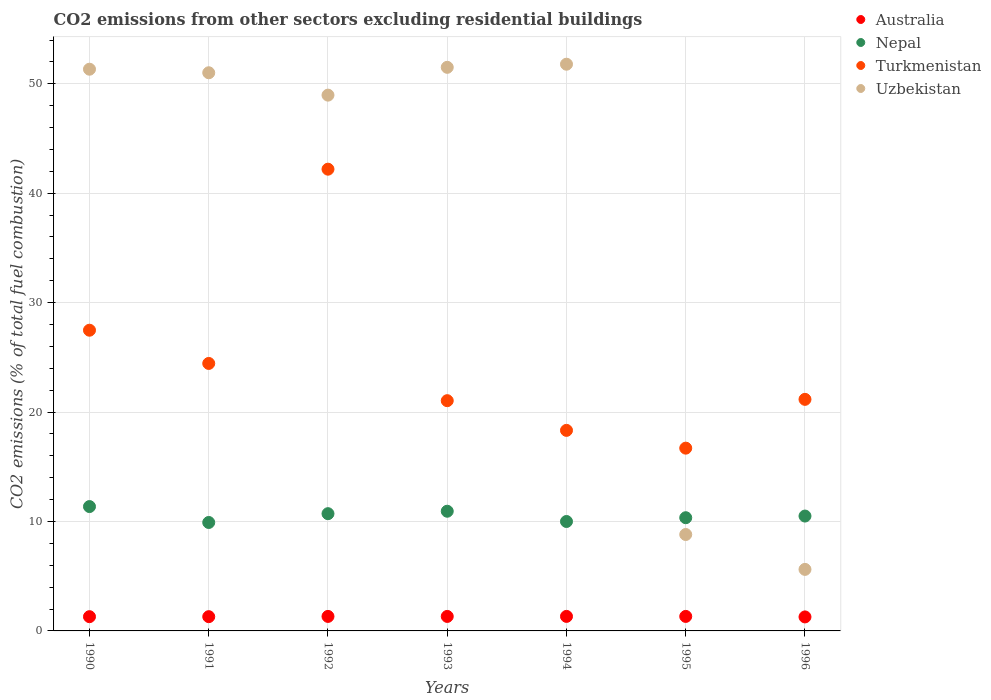What is the total CO2 emitted in Uzbekistan in 1991?
Offer a very short reply. 51.01. Across all years, what is the maximum total CO2 emitted in Turkmenistan?
Offer a terse response. 42.19. Across all years, what is the minimum total CO2 emitted in Australia?
Make the answer very short. 1.28. In which year was the total CO2 emitted in Turkmenistan maximum?
Your answer should be compact. 1992. What is the total total CO2 emitted in Uzbekistan in the graph?
Offer a terse response. 269.02. What is the difference between the total CO2 emitted in Uzbekistan in 1990 and that in 1995?
Give a very brief answer. 42.52. What is the difference between the total CO2 emitted in Uzbekistan in 1993 and the total CO2 emitted in Australia in 1996?
Ensure brevity in your answer.  50.22. What is the average total CO2 emitted in Uzbekistan per year?
Provide a short and direct response. 38.43. In the year 1996, what is the difference between the total CO2 emitted in Nepal and total CO2 emitted in Turkmenistan?
Provide a succinct answer. -10.66. In how many years, is the total CO2 emitted in Turkmenistan greater than 32?
Provide a short and direct response. 1. What is the ratio of the total CO2 emitted in Turkmenistan in 1991 to that in 1992?
Make the answer very short. 0.58. Is the total CO2 emitted in Turkmenistan in 1990 less than that in 1996?
Ensure brevity in your answer.  No. Is the difference between the total CO2 emitted in Nepal in 1990 and 1991 greater than the difference between the total CO2 emitted in Turkmenistan in 1990 and 1991?
Your response must be concise. No. What is the difference between the highest and the second highest total CO2 emitted in Nepal?
Keep it short and to the point. 0.43. What is the difference between the highest and the lowest total CO2 emitted in Uzbekistan?
Your response must be concise. 46.16. In how many years, is the total CO2 emitted in Turkmenistan greater than the average total CO2 emitted in Turkmenistan taken over all years?
Your response must be concise. 2. Is it the case that in every year, the sum of the total CO2 emitted in Turkmenistan and total CO2 emitted in Uzbekistan  is greater than the total CO2 emitted in Australia?
Provide a succinct answer. Yes. Is the total CO2 emitted in Nepal strictly greater than the total CO2 emitted in Turkmenistan over the years?
Provide a succinct answer. No. Is the total CO2 emitted in Australia strictly less than the total CO2 emitted in Turkmenistan over the years?
Your answer should be very brief. Yes. How many dotlines are there?
Offer a very short reply. 4. What is the difference between two consecutive major ticks on the Y-axis?
Provide a succinct answer. 10. Are the values on the major ticks of Y-axis written in scientific E-notation?
Ensure brevity in your answer.  No. Does the graph contain any zero values?
Keep it short and to the point. No. Does the graph contain grids?
Provide a short and direct response. Yes. How many legend labels are there?
Your response must be concise. 4. How are the legend labels stacked?
Your answer should be compact. Vertical. What is the title of the graph?
Provide a succinct answer. CO2 emissions from other sectors excluding residential buildings. Does "Antigua and Barbuda" appear as one of the legend labels in the graph?
Provide a succinct answer. No. What is the label or title of the Y-axis?
Your response must be concise. CO2 emissions (% of total fuel combustion). What is the CO2 emissions (% of total fuel combustion) of Australia in 1990?
Keep it short and to the point. 1.3. What is the CO2 emissions (% of total fuel combustion) of Nepal in 1990?
Provide a short and direct response. 11.36. What is the CO2 emissions (% of total fuel combustion) of Turkmenistan in 1990?
Your answer should be very brief. 27.48. What is the CO2 emissions (% of total fuel combustion) of Uzbekistan in 1990?
Give a very brief answer. 51.33. What is the CO2 emissions (% of total fuel combustion) in Australia in 1991?
Give a very brief answer. 1.3. What is the CO2 emissions (% of total fuel combustion) in Nepal in 1991?
Make the answer very short. 9.91. What is the CO2 emissions (% of total fuel combustion) in Turkmenistan in 1991?
Your response must be concise. 24.44. What is the CO2 emissions (% of total fuel combustion) in Uzbekistan in 1991?
Your response must be concise. 51.01. What is the CO2 emissions (% of total fuel combustion) of Australia in 1992?
Give a very brief answer. 1.33. What is the CO2 emissions (% of total fuel combustion) in Nepal in 1992?
Provide a short and direct response. 10.71. What is the CO2 emissions (% of total fuel combustion) of Turkmenistan in 1992?
Make the answer very short. 42.19. What is the CO2 emissions (% of total fuel combustion) of Uzbekistan in 1992?
Ensure brevity in your answer.  48.96. What is the CO2 emissions (% of total fuel combustion) of Australia in 1993?
Keep it short and to the point. 1.32. What is the CO2 emissions (% of total fuel combustion) of Nepal in 1993?
Provide a succinct answer. 10.94. What is the CO2 emissions (% of total fuel combustion) of Turkmenistan in 1993?
Your answer should be compact. 21.04. What is the CO2 emissions (% of total fuel combustion) in Uzbekistan in 1993?
Your answer should be very brief. 51.5. What is the CO2 emissions (% of total fuel combustion) of Australia in 1994?
Your answer should be compact. 1.33. What is the CO2 emissions (% of total fuel combustion) of Nepal in 1994?
Provide a succinct answer. 10. What is the CO2 emissions (% of total fuel combustion) in Turkmenistan in 1994?
Provide a short and direct response. 18.33. What is the CO2 emissions (% of total fuel combustion) in Uzbekistan in 1994?
Your answer should be very brief. 51.79. What is the CO2 emissions (% of total fuel combustion) of Australia in 1995?
Keep it short and to the point. 1.33. What is the CO2 emissions (% of total fuel combustion) in Nepal in 1995?
Your response must be concise. 10.34. What is the CO2 emissions (% of total fuel combustion) of Turkmenistan in 1995?
Your answer should be very brief. 16.7. What is the CO2 emissions (% of total fuel combustion) in Uzbekistan in 1995?
Offer a very short reply. 8.81. What is the CO2 emissions (% of total fuel combustion) of Australia in 1996?
Your answer should be very brief. 1.28. What is the CO2 emissions (% of total fuel combustion) in Nepal in 1996?
Make the answer very short. 10.5. What is the CO2 emissions (% of total fuel combustion) of Turkmenistan in 1996?
Offer a terse response. 21.16. What is the CO2 emissions (% of total fuel combustion) in Uzbekistan in 1996?
Your answer should be compact. 5.62. Across all years, what is the maximum CO2 emissions (% of total fuel combustion) in Australia?
Ensure brevity in your answer.  1.33. Across all years, what is the maximum CO2 emissions (% of total fuel combustion) of Nepal?
Ensure brevity in your answer.  11.36. Across all years, what is the maximum CO2 emissions (% of total fuel combustion) of Turkmenistan?
Keep it short and to the point. 42.19. Across all years, what is the maximum CO2 emissions (% of total fuel combustion) of Uzbekistan?
Make the answer very short. 51.79. Across all years, what is the minimum CO2 emissions (% of total fuel combustion) in Australia?
Give a very brief answer. 1.28. Across all years, what is the minimum CO2 emissions (% of total fuel combustion) in Nepal?
Provide a succinct answer. 9.91. Across all years, what is the minimum CO2 emissions (% of total fuel combustion) in Turkmenistan?
Keep it short and to the point. 16.7. Across all years, what is the minimum CO2 emissions (% of total fuel combustion) of Uzbekistan?
Offer a very short reply. 5.62. What is the total CO2 emissions (% of total fuel combustion) in Australia in the graph?
Provide a short and direct response. 9.19. What is the total CO2 emissions (% of total fuel combustion) in Nepal in the graph?
Ensure brevity in your answer.  73.77. What is the total CO2 emissions (% of total fuel combustion) in Turkmenistan in the graph?
Keep it short and to the point. 171.35. What is the total CO2 emissions (% of total fuel combustion) of Uzbekistan in the graph?
Ensure brevity in your answer.  269.02. What is the difference between the CO2 emissions (% of total fuel combustion) of Australia in 1990 and that in 1991?
Your answer should be very brief. -0. What is the difference between the CO2 emissions (% of total fuel combustion) of Nepal in 1990 and that in 1991?
Give a very brief answer. 1.45. What is the difference between the CO2 emissions (% of total fuel combustion) of Turkmenistan in 1990 and that in 1991?
Provide a short and direct response. 3.04. What is the difference between the CO2 emissions (% of total fuel combustion) of Uzbekistan in 1990 and that in 1991?
Your answer should be very brief. 0.32. What is the difference between the CO2 emissions (% of total fuel combustion) of Australia in 1990 and that in 1992?
Ensure brevity in your answer.  -0.02. What is the difference between the CO2 emissions (% of total fuel combustion) in Nepal in 1990 and that in 1992?
Make the answer very short. 0.65. What is the difference between the CO2 emissions (% of total fuel combustion) of Turkmenistan in 1990 and that in 1992?
Ensure brevity in your answer.  -14.72. What is the difference between the CO2 emissions (% of total fuel combustion) in Uzbekistan in 1990 and that in 1992?
Provide a short and direct response. 2.37. What is the difference between the CO2 emissions (% of total fuel combustion) in Australia in 1990 and that in 1993?
Give a very brief answer. -0.02. What is the difference between the CO2 emissions (% of total fuel combustion) in Nepal in 1990 and that in 1993?
Provide a short and direct response. 0.43. What is the difference between the CO2 emissions (% of total fuel combustion) in Turkmenistan in 1990 and that in 1993?
Provide a short and direct response. 6.44. What is the difference between the CO2 emissions (% of total fuel combustion) of Uzbekistan in 1990 and that in 1993?
Offer a very short reply. -0.17. What is the difference between the CO2 emissions (% of total fuel combustion) in Australia in 1990 and that in 1994?
Provide a short and direct response. -0.03. What is the difference between the CO2 emissions (% of total fuel combustion) in Nepal in 1990 and that in 1994?
Provide a short and direct response. 1.36. What is the difference between the CO2 emissions (% of total fuel combustion) of Turkmenistan in 1990 and that in 1994?
Your answer should be very brief. 9.15. What is the difference between the CO2 emissions (% of total fuel combustion) in Uzbekistan in 1990 and that in 1994?
Offer a very short reply. -0.46. What is the difference between the CO2 emissions (% of total fuel combustion) in Australia in 1990 and that in 1995?
Your answer should be very brief. -0.02. What is the difference between the CO2 emissions (% of total fuel combustion) in Nepal in 1990 and that in 1995?
Your answer should be very brief. 1.02. What is the difference between the CO2 emissions (% of total fuel combustion) of Turkmenistan in 1990 and that in 1995?
Ensure brevity in your answer.  10.78. What is the difference between the CO2 emissions (% of total fuel combustion) in Uzbekistan in 1990 and that in 1995?
Your response must be concise. 42.52. What is the difference between the CO2 emissions (% of total fuel combustion) in Australia in 1990 and that in 1996?
Offer a terse response. 0.02. What is the difference between the CO2 emissions (% of total fuel combustion) in Nepal in 1990 and that in 1996?
Make the answer very short. 0.87. What is the difference between the CO2 emissions (% of total fuel combustion) in Turkmenistan in 1990 and that in 1996?
Make the answer very short. 6.32. What is the difference between the CO2 emissions (% of total fuel combustion) of Uzbekistan in 1990 and that in 1996?
Your response must be concise. 45.71. What is the difference between the CO2 emissions (% of total fuel combustion) of Australia in 1991 and that in 1992?
Keep it short and to the point. -0.02. What is the difference between the CO2 emissions (% of total fuel combustion) of Nepal in 1991 and that in 1992?
Give a very brief answer. -0.8. What is the difference between the CO2 emissions (% of total fuel combustion) in Turkmenistan in 1991 and that in 1992?
Provide a succinct answer. -17.75. What is the difference between the CO2 emissions (% of total fuel combustion) in Uzbekistan in 1991 and that in 1992?
Provide a succinct answer. 2.04. What is the difference between the CO2 emissions (% of total fuel combustion) of Australia in 1991 and that in 1993?
Your answer should be very brief. -0.02. What is the difference between the CO2 emissions (% of total fuel combustion) of Nepal in 1991 and that in 1993?
Your answer should be very brief. -1.03. What is the difference between the CO2 emissions (% of total fuel combustion) of Turkmenistan in 1991 and that in 1993?
Offer a very short reply. 3.4. What is the difference between the CO2 emissions (% of total fuel combustion) of Uzbekistan in 1991 and that in 1993?
Give a very brief answer. -0.5. What is the difference between the CO2 emissions (% of total fuel combustion) of Australia in 1991 and that in 1994?
Your answer should be very brief. -0.03. What is the difference between the CO2 emissions (% of total fuel combustion) of Nepal in 1991 and that in 1994?
Ensure brevity in your answer.  -0.09. What is the difference between the CO2 emissions (% of total fuel combustion) in Turkmenistan in 1991 and that in 1994?
Give a very brief answer. 6.12. What is the difference between the CO2 emissions (% of total fuel combustion) in Uzbekistan in 1991 and that in 1994?
Give a very brief answer. -0.78. What is the difference between the CO2 emissions (% of total fuel combustion) in Australia in 1991 and that in 1995?
Provide a succinct answer. -0.02. What is the difference between the CO2 emissions (% of total fuel combustion) in Nepal in 1991 and that in 1995?
Your answer should be very brief. -0.43. What is the difference between the CO2 emissions (% of total fuel combustion) in Turkmenistan in 1991 and that in 1995?
Your answer should be very brief. 7.74. What is the difference between the CO2 emissions (% of total fuel combustion) of Uzbekistan in 1991 and that in 1995?
Your answer should be compact. 42.2. What is the difference between the CO2 emissions (% of total fuel combustion) in Australia in 1991 and that in 1996?
Keep it short and to the point. 0.02. What is the difference between the CO2 emissions (% of total fuel combustion) of Nepal in 1991 and that in 1996?
Make the answer very short. -0.59. What is the difference between the CO2 emissions (% of total fuel combustion) in Turkmenistan in 1991 and that in 1996?
Your answer should be compact. 3.28. What is the difference between the CO2 emissions (% of total fuel combustion) in Uzbekistan in 1991 and that in 1996?
Provide a succinct answer. 45.38. What is the difference between the CO2 emissions (% of total fuel combustion) of Australia in 1992 and that in 1993?
Give a very brief answer. 0. What is the difference between the CO2 emissions (% of total fuel combustion) of Nepal in 1992 and that in 1993?
Make the answer very short. -0.22. What is the difference between the CO2 emissions (% of total fuel combustion) of Turkmenistan in 1992 and that in 1993?
Offer a very short reply. 21.15. What is the difference between the CO2 emissions (% of total fuel combustion) of Uzbekistan in 1992 and that in 1993?
Make the answer very short. -2.54. What is the difference between the CO2 emissions (% of total fuel combustion) in Australia in 1992 and that in 1994?
Make the answer very short. -0. What is the difference between the CO2 emissions (% of total fuel combustion) in Turkmenistan in 1992 and that in 1994?
Provide a short and direct response. 23.87. What is the difference between the CO2 emissions (% of total fuel combustion) in Uzbekistan in 1992 and that in 1994?
Keep it short and to the point. -2.83. What is the difference between the CO2 emissions (% of total fuel combustion) in Australia in 1992 and that in 1995?
Provide a short and direct response. 0. What is the difference between the CO2 emissions (% of total fuel combustion) in Nepal in 1992 and that in 1995?
Provide a short and direct response. 0.37. What is the difference between the CO2 emissions (% of total fuel combustion) of Turkmenistan in 1992 and that in 1995?
Your answer should be compact. 25.49. What is the difference between the CO2 emissions (% of total fuel combustion) in Uzbekistan in 1992 and that in 1995?
Provide a short and direct response. 40.15. What is the difference between the CO2 emissions (% of total fuel combustion) in Australia in 1992 and that in 1996?
Give a very brief answer. 0.05. What is the difference between the CO2 emissions (% of total fuel combustion) in Nepal in 1992 and that in 1996?
Keep it short and to the point. 0.22. What is the difference between the CO2 emissions (% of total fuel combustion) of Turkmenistan in 1992 and that in 1996?
Your response must be concise. 21.03. What is the difference between the CO2 emissions (% of total fuel combustion) of Uzbekistan in 1992 and that in 1996?
Your answer should be compact. 43.34. What is the difference between the CO2 emissions (% of total fuel combustion) of Australia in 1993 and that in 1994?
Your answer should be compact. -0. What is the difference between the CO2 emissions (% of total fuel combustion) of Turkmenistan in 1993 and that in 1994?
Provide a short and direct response. 2.71. What is the difference between the CO2 emissions (% of total fuel combustion) of Uzbekistan in 1993 and that in 1994?
Make the answer very short. -0.28. What is the difference between the CO2 emissions (% of total fuel combustion) in Australia in 1993 and that in 1995?
Offer a very short reply. -0. What is the difference between the CO2 emissions (% of total fuel combustion) in Nepal in 1993 and that in 1995?
Provide a short and direct response. 0.59. What is the difference between the CO2 emissions (% of total fuel combustion) of Turkmenistan in 1993 and that in 1995?
Offer a terse response. 4.34. What is the difference between the CO2 emissions (% of total fuel combustion) in Uzbekistan in 1993 and that in 1995?
Provide a succinct answer. 42.69. What is the difference between the CO2 emissions (% of total fuel combustion) in Australia in 1993 and that in 1996?
Provide a succinct answer. 0.04. What is the difference between the CO2 emissions (% of total fuel combustion) of Nepal in 1993 and that in 1996?
Your answer should be very brief. 0.44. What is the difference between the CO2 emissions (% of total fuel combustion) in Turkmenistan in 1993 and that in 1996?
Your response must be concise. -0.12. What is the difference between the CO2 emissions (% of total fuel combustion) of Uzbekistan in 1993 and that in 1996?
Make the answer very short. 45.88. What is the difference between the CO2 emissions (% of total fuel combustion) in Australia in 1994 and that in 1995?
Your answer should be very brief. 0. What is the difference between the CO2 emissions (% of total fuel combustion) of Nepal in 1994 and that in 1995?
Provide a succinct answer. -0.34. What is the difference between the CO2 emissions (% of total fuel combustion) of Turkmenistan in 1994 and that in 1995?
Provide a succinct answer. 1.63. What is the difference between the CO2 emissions (% of total fuel combustion) of Uzbekistan in 1994 and that in 1995?
Offer a terse response. 42.98. What is the difference between the CO2 emissions (% of total fuel combustion) in Australia in 1994 and that in 1996?
Provide a succinct answer. 0.05. What is the difference between the CO2 emissions (% of total fuel combustion) of Nepal in 1994 and that in 1996?
Make the answer very short. -0.5. What is the difference between the CO2 emissions (% of total fuel combustion) in Turkmenistan in 1994 and that in 1996?
Your answer should be compact. -2.83. What is the difference between the CO2 emissions (% of total fuel combustion) in Uzbekistan in 1994 and that in 1996?
Your response must be concise. 46.16. What is the difference between the CO2 emissions (% of total fuel combustion) of Australia in 1995 and that in 1996?
Your response must be concise. 0.05. What is the difference between the CO2 emissions (% of total fuel combustion) of Nepal in 1995 and that in 1996?
Offer a terse response. -0.15. What is the difference between the CO2 emissions (% of total fuel combustion) of Turkmenistan in 1995 and that in 1996?
Offer a terse response. -4.46. What is the difference between the CO2 emissions (% of total fuel combustion) of Uzbekistan in 1995 and that in 1996?
Give a very brief answer. 3.19. What is the difference between the CO2 emissions (% of total fuel combustion) in Australia in 1990 and the CO2 emissions (% of total fuel combustion) in Nepal in 1991?
Ensure brevity in your answer.  -8.61. What is the difference between the CO2 emissions (% of total fuel combustion) in Australia in 1990 and the CO2 emissions (% of total fuel combustion) in Turkmenistan in 1991?
Keep it short and to the point. -23.14. What is the difference between the CO2 emissions (% of total fuel combustion) of Australia in 1990 and the CO2 emissions (% of total fuel combustion) of Uzbekistan in 1991?
Offer a very short reply. -49.7. What is the difference between the CO2 emissions (% of total fuel combustion) of Nepal in 1990 and the CO2 emissions (% of total fuel combustion) of Turkmenistan in 1991?
Give a very brief answer. -13.08. What is the difference between the CO2 emissions (% of total fuel combustion) in Nepal in 1990 and the CO2 emissions (% of total fuel combustion) in Uzbekistan in 1991?
Provide a short and direct response. -39.64. What is the difference between the CO2 emissions (% of total fuel combustion) in Turkmenistan in 1990 and the CO2 emissions (% of total fuel combustion) in Uzbekistan in 1991?
Keep it short and to the point. -23.53. What is the difference between the CO2 emissions (% of total fuel combustion) of Australia in 1990 and the CO2 emissions (% of total fuel combustion) of Nepal in 1992?
Provide a short and direct response. -9.41. What is the difference between the CO2 emissions (% of total fuel combustion) of Australia in 1990 and the CO2 emissions (% of total fuel combustion) of Turkmenistan in 1992?
Your answer should be compact. -40.89. What is the difference between the CO2 emissions (% of total fuel combustion) in Australia in 1990 and the CO2 emissions (% of total fuel combustion) in Uzbekistan in 1992?
Your response must be concise. -47.66. What is the difference between the CO2 emissions (% of total fuel combustion) in Nepal in 1990 and the CO2 emissions (% of total fuel combustion) in Turkmenistan in 1992?
Provide a short and direct response. -30.83. What is the difference between the CO2 emissions (% of total fuel combustion) in Nepal in 1990 and the CO2 emissions (% of total fuel combustion) in Uzbekistan in 1992?
Keep it short and to the point. -37.6. What is the difference between the CO2 emissions (% of total fuel combustion) of Turkmenistan in 1990 and the CO2 emissions (% of total fuel combustion) of Uzbekistan in 1992?
Make the answer very short. -21.48. What is the difference between the CO2 emissions (% of total fuel combustion) in Australia in 1990 and the CO2 emissions (% of total fuel combustion) in Nepal in 1993?
Make the answer very short. -9.64. What is the difference between the CO2 emissions (% of total fuel combustion) of Australia in 1990 and the CO2 emissions (% of total fuel combustion) of Turkmenistan in 1993?
Your answer should be very brief. -19.74. What is the difference between the CO2 emissions (% of total fuel combustion) of Australia in 1990 and the CO2 emissions (% of total fuel combustion) of Uzbekistan in 1993?
Keep it short and to the point. -50.2. What is the difference between the CO2 emissions (% of total fuel combustion) in Nepal in 1990 and the CO2 emissions (% of total fuel combustion) in Turkmenistan in 1993?
Your answer should be very brief. -9.68. What is the difference between the CO2 emissions (% of total fuel combustion) of Nepal in 1990 and the CO2 emissions (% of total fuel combustion) of Uzbekistan in 1993?
Offer a very short reply. -40.14. What is the difference between the CO2 emissions (% of total fuel combustion) of Turkmenistan in 1990 and the CO2 emissions (% of total fuel combustion) of Uzbekistan in 1993?
Provide a succinct answer. -24.02. What is the difference between the CO2 emissions (% of total fuel combustion) of Australia in 1990 and the CO2 emissions (% of total fuel combustion) of Nepal in 1994?
Offer a very short reply. -8.7. What is the difference between the CO2 emissions (% of total fuel combustion) in Australia in 1990 and the CO2 emissions (% of total fuel combustion) in Turkmenistan in 1994?
Provide a succinct answer. -17.03. What is the difference between the CO2 emissions (% of total fuel combustion) of Australia in 1990 and the CO2 emissions (% of total fuel combustion) of Uzbekistan in 1994?
Give a very brief answer. -50.49. What is the difference between the CO2 emissions (% of total fuel combustion) in Nepal in 1990 and the CO2 emissions (% of total fuel combustion) in Turkmenistan in 1994?
Your answer should be compact. -6.96. What is the difference between the CO2 emissions (% of total fuel combustion) of Nepal in 1990 and the CO2 emissions (% of total fuel combustion) of Uzbekistan in 1994?
Give a very brief answer. -40.42. What is the difference between the CO2 emissions (% of total fuel combustion) in Turkmenistan in 1990 and the CO2 emissions (% of total fuel combustion) in Uzbekistan in 1994?
Your answer should be very brief. -24.31. What is the difference between the CO2 emissions (% of total fuel combustion) in Australia in 1990 and the CO2 emissions (% of total fuel combustion) in Nepal in 1995?
Provide a short and direct response. -9.04. What is the difference between the CO2 emissions (% of total fuel combustion) in Australia in 1990 and the CO2 emissions (% of total fuel combustion) in Turkmenistan in 1995?
Provide a short and direct response. -15.4. What is the difference between the CO2 emissions (% of total fuel combustion) in Australia in 1990 and the CO2 emissions (% of total fuel combustion) in Uzbekistan in 1995?
Keep it short and to the point. -7.51. What is the difference between the CO2 emissions (% of total fuel combustion) in Nepal in 1990 and the CO2 emissions (% of total fuel combustion) in Turkmenistan in 1995?
Give a very brief answer. -5.34. What is the difference between the CO2 emissions (% of total fuel combustion) of Nepal in 1990 and the CO2 emissions (% of total fuel combustion) of Uzbekistan in 1995?
Your answer should be compact. 2.55. What is the difference between the CO2 emissions (% of total fuel combustion) of Turkmenistan in 1990 and the CO2 emissions (% of total fuel combustion) of Uzbekistan in 1995?
Provide a short and direct response. 18.67. What is the difference between the CO2 emissions (% of total fuel combustion) of Australia in 1990 and the CO2 emissions (% of total fuel combustion) of Nepal in 1996?
Provide a succinct answer. -9.2. What is the difference between the CO2 emissions (% of total fuel combustion) in Australia in 1990 and the CO2 emissions (% of total fuel combustion) in Turkmenistan in 1996?
Keep it short and to the point. -19.86. What is the difference between the CO2 emissions (% of total fuel combustion) of Australia in 1990 and the CO2 emissions (% of total fuel combustion) of Uzbekistan in 1996?
Your response must be concise. -4.32. What is the difference between the CO2 emissions (% of total fuel combustion) in Nepal in 1990 and the CO2 emissions (% of total fuel combustion) in Turkmenistan in 1996?
Ensure brevity in your answer.  -9.8. What is the difference between the CO2 emissions (% of total fuel combustion) of Nepal in 1990 and the CO2 emissions (% of total fuel combustion) of Uzbekistan in 1996?
Your response must be concise. 5.74. What is the difference between the CO2 emissions (% of total fuel combustion) of Turkmenistan in 1990 and the CO2 emissions (% of total fuel combustion) of Uzbekistan in 1996?
Ensure brevity in your answer.  21.86. What is the difference between the CO2 emissions (% of total fuel combustion) in Australia in 1991 and the CO2 emissions (% of total fuel combustion) in Nepal in 1992?
Make the answer very short. -9.41. What is the difference between the CO2 emissions (% of total fuel combustion) in Australia in 1991 and the CO2 emissions (% of total fuel combustion) in Turkmenistan in 1992?
Provide a short and direct response. -40.89. What is the difference between the CO2 emissions (% of total fuel combustion) in Australia in 1991 and the CO2 emissions (% of total fuel combustion) in Uzbekistan in 1992?
Make the answer very short. -47.66. What is the difference between the CO2 emissions (% of total fuel combustion) in Nepal in 1991 and the CO2 emissions (% of total fuel combustion) in Turkmenistan in 1992?
Make the answer very short. -32.28. What is the difference between the CO2 emissions (% of total fuel combustion) of Nepal in 1991 and the CO2 emissions (% of total fuel combustion) of Uzbekistan in 1992?
Provide a succinct answer. -39.05. What is the difference between the CO2 emissions (% of total fuel combustion) of Turkmenistan in 1991 and the CO2 emissions (% of total fuel combustion) of Uzbekistan in 1992?
Provide a succinct answer. -24.52. What is the difference between the CO2 emissions (% of total fuel combustion) of Australia in 1991 and the CO2 emissions (% of total fuel combustion) of Nepal in 1993?
Ensure brevity in your answer.  -9.64. What is the difference between the CO2 emissions (% of total fuel combustion) of Australia in 1991 and the CO2 emissions (% of total fuel combustion) of Turkmenistan in 1993?
Give a very brief answer. -19.74. What is the difference between the CO2 emissions (% of total fuel combustion) in Australia in 1991 and the CO2 emissions (% of total fuel combustion) in Uzbekistan in 1993?
Your answer should be very brief. -50.2. What is the difference between the CO2 emissions (% of total fuel combustion) of Nepal in 1991 and the CO2 emissions (% of total fuel combustion) of Turkmenistan in 1993?
Your response must be concise. -11.13. What is the difference between the CO2 emissions (% of total fuel combustion) of Nepal in 1991 and the CO2 emissions (% of total fuel combustion) of Uzbekistan in 1993?
Keep it short and to the point. -41.59. What is the difference between the CO2 emissions (% of total fuel combustion) in Turkmenistan in 1991 and the CO2 emissions (% of total fuel combustion) in Uzbekistan in 1993?
Keep it short and to the point. -27.06. What is the difference between the CO2 emissions (% of total fuel combustion) in Australia in 1991 and the CO2 emissions (% of total fuel combustion) in Nepal in 1994?
Provide a succinct answer. -8.7. What is the difference between the CO2 emissions (% of total fuel combustion) in Australia in 1991 and the CO2 emissions (% of total fuel combustion) in Turkmenistan in 1994?
Offer a terse response. -17.02. What is the difference between the CO2 emissions (% of total fuel combustion) in Australia in 1991 and the CO2 emissions (% of total fuel combustion) in Uzbekistan in 1994?
Your answer should be very brief. -50.49. What is the difference between the CO2 emissions (% of total fuel combustion) of Nepal in 1991 and the CO2 emissions (% of total fuel combustion) of Turkmenistan in 1994?
Your response must be concise. -8.42. What is the difference between the CO2 emissions (% of total fuel combustion) in Nepal in 1991 and the CO2 emissions (% of total fuel combustion) in Uzbekistan in 1994?
Give a very brief answer. -41.88. What is the difference between the CO2 emissions (% of total fuel combustion) of Turkmenistan in 1991 and the CO2 emissions (% of total fuel combustion) of Uzbekistan in 1994?
Provide a short and direct response. -27.34. What is the difference between the CO2 emissions (% of total fuel combustion) of Australia in 1991 and the CO2 emissions (% of total fuel combustion) of Nepal in 1995?
Give a very brief answer. -9.04. What is the difference between the CO2 emissions (% of total fuel combustion) of Australia in 1991 and the CO2 emissions (% of total fuel combustion) of Turkmenistan in 1995?
Your answer should be compact. -15.4. What is the difference between the CO2 emissions (% of total fuel combustion) in Australia in 1991 and the CO2 emissions (% of total fuel combustion) in Uzbekistan in 1995?
Provide a short and direct response. -7.51. What is the difference between the CO2 emissions (% of total fuel combustion) in Nepal in 1991 and the CO2 emissions (% of total fuel combustion) in Turkmenistan in 1995?
Provide a short and direct response. -6.79. What is the difference between the CO2 emissions (% of total fuel combustion) of Nepal in 1991 and the CO2 emissions (% of total fuel combustion) of Uzbekistan in 1995?
Ensure brevity in your answer.  1.1. What is the difference between the CO2 emissions (% of total fuel combustion) in Turkmenistan in 1991 and the CO2 emissions (% of total fuel combustion) in Uzbekistan in 1995?
Make the answer very short. 15.63. What is the difference between the CO2 emissions (% of total fuel combustion) of Australia in 1991 and the CO2 emissions (% of total fuel combustion) of Nepal in 1996?
Your answer should be very brief. -9.19. What is the difference between the CO2 emissions (% of total fuel combustion) of Australia in 1991 and the CO2 emissions (% of total fuel combustion) of Turkmenistan in 1996?
Keep it short and to the point. -19.86. What is the difference between the CO2 emissions (% of total fuel combustion) in Australia in 1991 and the CO2 emissions (% of total fuel combustion) in Uzbekistan in 1996?
Give a very brief answer. -4.32. What is the difference between the CO2 emissions (% of total fuel combustion) of Nepal in 1991 and the CO2 emissions (% of total fuel combustion) of Turkmenistan in 1996?
Your response must be concise. -11.25. What is the difference between the CO2 emissions (% of total fuel combustion) of Nepal in 1991 and the CO2 emissions (% of total fuel combustion) of Uzbekistan in 1996?
Offer a terse response. 4.29. What is the difference between the CO2 emissions (% of total fuel combustion) of Turkmenistan in 1991 and the CO2 emissions (% of total fuel combustion) of Uzbekistan in 1996?
Make the answer very short. 18.82. What is the difference between the CO2 emissions (% of total fuel combustion) of Australia in 1992 and the CO2 emissions (% of total fuel combustion) of Nepal in 1993?
Give a very brief answer. -9.61. What is the difference between the CO2 emissions (% of total fuel combustion) of Australia in 1992 and the CO2 emissions (% of total fuel combustion) of Turkmenistan in 1993?
Offer a terse response. -19.71. What is the difference between the CO2 emissions (% of total fuel combustion) in Australia in 1992 and the CO2 emissions (% of total fuel combustion) in Uzbekistan in 1993?
Provide a succinct answer. -50.18. What is the difference between the CO2 emissions (% of total fuel combustion) in Nepal in 1992 and the CO2 emissions (% of total fuel combustion) in Turkmenistan in 1993?
Your response must be concise. -10.33. What is the difference between the CO2 emissions (% of total fuel combustion) in Nepal in 1992 and the CO2 emissions (% of total fuel combustion) in Uzbekistan in 1993?
Your answer should be very brief. -40.79. What is the difference between the CO2 emissions (% of total fuel combustion) of Turkmenistan in 1992 and the CO2 emissions (% of total fuel combustion) of Uzbekistan in 1993?
Provide a short and direct response. -9.31. What is the difference between the CO2 emissions (% of total fuel combustion) of Australia in 1992 and the CO2 emissions (% of total fuel combustion) of Nepal in 1994?
Your answer should be compact. -8.67. What is the difference between the CO2 emissions (% of total fuel combustion) of Australia in 1992 and the CO2 emissions (% of total fuel combustion) of Turkmenistan in 1994?
Your answer should be compact. -17. What is the difference between the CO2 emissions (% of total fuel combustion) in Australia in 1992 and the CO2 emissions (% of total fuel combustion) in Uzbekistan in 1994?
Provide a short and direct response. -50.46. What is the difference between the CO2 emissions (% of total fuel combustion) of Nepal in 1992 and the CO2 emissions (% of total fuel combustion) of Turkmenistan in 1994?
Make the answer very short. -7.61. What is the difference between the CO2 emissions (% of total fuel combustion) in Nepal in 1992 and the CO2 emissions (% of total fuel combustion) in Uzbekistan in 1994?
Give a very brief answer. -41.07. What is the difference between the CO2 emissions (% of total fuel combustion) of Turkmenistan in 1992 and the CO2 emissions (% of total fuel combustion) of Uzbekistan in 1994?
Make the answer very short. -9.59. What is the difference between the CO2 emissions (% of total fuel combustion) of Australia in 1992 and the CO2 emissions (% of total fuel combustion) of Nepal in 1995?
Your answer should be compact. -9.02. What is the difference between the CO2 emissions (% of total fuel combustion) in Australia in 1992 and the CO2 emissions (% of total fuel combustion) in Turkmenistan in 1995?
Offer a terse response. -15.38. What is the difference between the CO2 emissions (% of total fuel combustion) of Australia in 1992 and the CO2 emissions (% of total fuel combustion) of Uzbekistan in 1995?
Keep it short and to the point. -7.49. What is the difference between the CO2 emissions (% of total fuel combustion) of Nepal in 1992 and the CO2 emissions (% of total fuel combustion) of Turkmenistan in 1995?
Keep it short and to the point. -5.99. What is the difference between the CO2 emissions (% of total fuel combustion) in Nepal in 1992 and the CO2 emissions (% of total fuel combustion) in Uzbekistan in 1995?
Ensure brevity in your answer.  1.9. What is the difference between the CO2 emissions (% of total fuel combustion) of Turkmenistan in 1992 and the CO2 emissions (% of total fuel combustion) of Uzbekistan in 1995?
Keep it short and to the point. 33.38. What is the difference between the CO2 emissions (% of total fuel combustion) in Australia in 1992 and the CO2 emissions (% of total fuel combustion) in Nepal in 1996?
Give a very brief answer. -9.17. What is the difference between the CO2 emissions (% of total fuel combustion) in Australia in 1992 and the CO2 emissions (% of total fuel combustion) in Turkmenistan in 1996?
Offer a terse response. -19.84. What is the difference between the CO2 emissions (% of total fuel combustion) of Australia in 1992 and the CO2 emissions (% of total fuel combustion) of Uzbekistan in 1996?
Make the answer very short. -4.3. What is the difference between the CO2 emissions (% of total fuel combustion) in Nepal in 1992 and the CO2 emissions (% of total fuel combustion) in Turkmenistan in 1996?
Offer a terse response. -10.45. What is the difference between the CO2 emissions (% of total fuel combustion) of Nepal in 1992 and the CO2 emissions (% of total fuel combustion) of Uzbekistan in 1996?
Keep it short and to the point. 5.09. What is the difference between the CO2 emissions (% of total fuel combustion) in Turkmenistan in 1992 and the CO2 emissions (% of total fuel combustion) in Uzbekistan in 1996?
Offer a terse response. 36.57. What is the difference between the CO2 emissions (% of total fuel combustion) of Australia in 1993 and the CO2 emissions (% of total fuel combustion) of Nepal in 1994?
Make the answer very short. -8.68. What is the difference between the CO2 emissions (% of total fuel combustion) in Australia in 1993 and the CO2 emissions (% of total fuel combustion) in Turkmenistan in 1994?
Provide a short and direct response. -17. What is the difference between the CO2 emissions (% of total fuel combustion) of Australia in 1993 and the CO2 emissions (% of total fuel combustion) of Uzbekistan in 1994?
Keep it short and to the point. -50.46. What is the difference between the CO2 emissions (% of total fuel combustion) in Nepal in 1993 and the CO2 emissions (% of total fuel combustion) in Turkmenistan in 1994?
Give a very brief answer. -7.39. What is the difference between the CO2 emissions (% of total fuel combustion) in Nepal in 1993 and the CO2 emissions (% of total fuel combustion) in Uzbekistan in 1994?
Your response must be concise. -40.85. What is the difference between the CO2 emissions (% of total fuel combustion) of Turkmenistan in 1993 and the CO2 emissions (% of total fuel combustion) of Uzbekistan in 1994?
Make the answer very short. -30.75. What is the difference between the CO2 emissions (% of total fuel combustion) of Australia in 1993 and the CO2 emissions (% of total fuel combustion) of Nepal in 1995?
Your response must be concise. -9.02. What is the difference between the CO2 emissions (% of total fuel combustion) of Australia in 1993 and the CO2 emissions (% of total fuel combustion) of Turkmenistan in 1995?
Offer a very short reply. -15.38. What is the difference between the CO2 emissions (% of total fuel combustion) in Australia in 1993 and the CO2 emissions (% of total fuel combustion) in Uzbekistan in 1995?
Your response must be concise. -7.49. What is the difference between the CO2 emissions (% of total fuel combustion) of Nepal in 1993 and the CO2 emissions (% of total fuel combustion) of Turkmenistan in 1995?
Make the answer very short. -5.76. What is the difference between the CO2 emissions (% of total fuel combustion) of Nepal in 1993 and the CO2 emissions (% of total fuel combustion) of Uzbekistan in 1995?
Make the answer very short. 2.13. What is the difference between the CO2 emissions (% of total fuel combustion) in Turkmenistan in 1993 and the CO2 emissions (% of total fuel combustion) in Uzbekistan in 1995?
Offer a very short reply. 12.23. What is the difference between the CO2 emissions (% of total fuel combustion) of Australia in 1993 and the CO2 emissions (% of total fuel combustion) of Nepal in 1996?
Your answer should be compact. -9.17. What is the difference between the CO2 emissions (% of total fuel combustion) of Australia in 1993 and the CO2 emissions (% of total fuel combustion) of Turkmenistan in 1996?
Make the answer very short. -19.84. What is the difference between the CO2 emissions (% of total fuel combustion) of Australia in 1993 and the CO2 emissions (% of total fuel combustion) of Uzbekistan in 1996?
Your answer should be very brief. -4.3. What is the difference between the CO2 emissions (% of total fuel combustion) of Nepal in 1993 and the CO2 emissions (% of total fuel combustion) of Turkmenistan in 1996?
Your response must be concise. -10.22. What is the difference between the CO2 emissions (% of total fuel combustion) in Nepal in 1993 and the CO2 emissions (% of total fuel combustion) in Uzbekistan in 1996?
Give a very brief answer. 5.31. What is the difference between the CO2 emissions (% of total fuel combustion) in Turkmenistan in 1993 and the CO2 emissions (% of total fuel combustion) in Uzbekistan in 1996?
Keep it short and to the point. 15.42. What is the difference between the CO2 emissions (% of total fuel combustion) of Australia in 1994 and the CO2 emissions (% of total fuel combustion) of Nepal in 1995?
Keep it short and to the point. -9.02. What is the difference between the CO2 emissions (% of total fuel combustion) of Australia in 1994 and the CO2 emissions (% of total fuel combustion) of Turkmenistan in 1995?
Provide a short and direct response. -15.37. What is the difference between the CO2 emissions (% of total fuel combustion) of Australia in 1994 and the CO2 emissions (% of total fuel combustion) of Uzbekistan in 1995?
Make the answer very short. -7.48. What is the difference between the CO2 emissions (% of total fuel combustion) in Nepal in 1994 and the CO2 emissions (% of total fuel combustion) in Turkmenistan in 1995?
Make the answer very short. -6.7. What is the difference between the CO2 emissions (% of total fuel combustion) of Nepal in 1994 and the CO2 emissions (% of total fuel combustion) of Uzbekistan in 1995?
Provide a succinct answer. 1.19. What is the difference between the CO2 emissions (% of total fuel combustion) of Turkmenistan in 1994 and the CO2 emissions (% of total fuel combustion) of Uzbekistan in 1995?
Your answer should be very brief. 9.52. What is the difference between the CO2 emissions (% of total fuel combustion) in Australia in 1994 and the CO2 emissions (% of total fuel combustion) in Nepal in 1996?
Provide a succinct answer. -9.17. What is the difference between the CO2 emissions (% of total fuel combustion) in Australia in 1994 and the CO2 emissions (% of total fuel combustion) in Turkmenistan in 1996?
Keep it short and to the point. -19.83. What is the difference between the CO2 emissions (% of total fuel combustion) of Australia in 1994 and the CO2 emissions (% of total fuel combustion) of Uzbekistan in 1996?
Ensure brevity in your answer.  -4.3. What is the difference between the CO2 emissions (% of total fuel combustion) in Nepal in 1994 and the CO2 emissions (% of total fuel combustion) in Turkmenistan in 1996?
Your response must be concise. -11.16. What is the difference between the CO2 emissions (% of total fuel combustion) in Nepal in 1994 and the CO2 emissions (% of total fuel combustion) in Uzbekistan in 1996?
Ensure brevity in your answer.  4.38. What is the difference between the CO2 emissions (% of total fuel combustion) in Turkmenistan in 1994 and the CO2 emissions (% of total fuel combustion) in Uzbekistan in 1996?
Your response must be concise. 12.7. What is the difference between the CO2 emissions (% of total fuel combustion) of Australia in 1995 and the CO2 emissions (% of total fuel combustion) of Nepal in 1996?
Make the answer very short. -9.17. What is the difference between the CO2 emissions (% of total fuel combustion) of Australia in 1995 and the CO2 emissions (% of total fuel combustion) of Turkmenistan in 1996?
Your answer should be compact. -19.84. What is the difference between the CO2 emissions (% of total fuel combustion) in Australia in 1995 and the CO2 emissions (% of total fuel combustion) in Uzbekistan in 1996?
Give a very brief answer. -4.3. What is the difference between the CO2 emissions (% of total fuel combustion) of Nepal in 1995 and the CO2 emissions (% of total fuel combustion) of Turkmenistan in 1996?
Make the answer very short. -10.82. What is the difference between the CO2 emissions (% of total fuel combustion) in Nepal in 1995 and the CO2 emissions (% of total fuel combustion) in Uzbekistan in 1996?
Your answer should be compact. 4.72. What is the difference between the CO2 emissions (% of total fuel combustion) in Turkmenistan in 1995 and the CO2 emissions (% of total fuel combustion) in Uzbekistan in 1996?
Keep it short and to the point. 11.08. What is the average CO2 emissions (% of total fuel combustion) of Australia per year?
Make the answer very short. 1.31. What is the average CO2 emissions (% of total fuel combustion) of Nepal per year?
Provide a succinct answer. 10.54. What is the average CO2 emissions (% of total fuel combustion) of Turkmenistan per year?
Offer a very short reply. 24.48. What is the average CO2 emissions (% of total fuel combustion) of Uzbekistan per year?
Give a very brief answer. 38.43. In the year 1990, what is the difference between the CO2 emissions (% of total fuel combustion) in Australia and CO2 emissions (% of total fuel combustion) in Nepal?
Keep it short and to the point. -10.06. In the year 1990, what is the difference between the CO2 emissions (% of total fuel combustion) of Australia and CO2 emissions (% of total fuel combustion) of Turkmenistan?
Ensure brevity in your answer.  -26.18. In the year 1990, what is the difference between the CO2 emissions (% of total fuel combustion) of Australia and CO2 emissions (% of total fuel combustion) of Uzbekistan?
Your answer should be very brief. -50.03. In the year 1990, what is the difference between the CO2 emissions (% of total fuel combustion) of Nepal and CO2 emissions (% of total fuel combustion) of Turkmenistan?
Offer a terse response. -16.12. In the year 1990, what is the difference between the CO2 emissions (% of total fuel combustion) of Nepal and CO2 emissions (% of total fuel combustion) of Uzbekistan?
Provide a short and direct response. -39.97. In the year 1990, what is the difference between the CO2 emissions (% of total fuel combustion) in Turkmenistan and CO2 emissions (% of total fuel combustion) in Uzbekistan?
Offer a terse response. -23.85. In the year 1991, what is the difference between the CO2 emissions (% of total fuel combustion) in Australia and CO2 emissions (% of total fuel combustion) in Nepal?
Offer a very short reply. -8.61. In the year 1991, what is the difference between the CO2 emissions (% of total fuel combustion) in Australia and CO2 emissions (% of total fuel combustion) in Turkmenistan?
Your answer should be very brief. -23.14. In the year 1991, what is the difference between the CO2 emissions (% of total fuel combustion) in Australia and CO2 emissions (% of total fuel combustion) in Uzbekistan?
Your answer should be compact. -49.7. In the year 1991, what is the difference between the CO2 emissions (% of total fuel combustion) in Nepal and CO2 emissions (% of total fuel combustion) in Turkmenistan?
Your response must be concise. -14.53. In the year 1991, what is the difference between the CO2 emissions (% of total fuel combustion) of Nepal and CO2 emissions (% of total fuel combustion) of Uzbekistan?
Provide a succinct answer. -41.1. In the year 1991, what is the difference between the CO2 emissions (% of total fuel combustion) of Turkmenistan and CO2 emissions (% of total fuel combustion) of Uzbekistan?
Your answer should be compact. -26.56. In the year 1992, what is the difference between the CO2 emissions (% of total fuel combustion) of Australia and CO2 emissions (% of total fuel combustion) of Nepal?
Your response must be concise. -9.39. In the year 1992, what is the difference between the CO2 emissions (% of total fuel combustion) in Australia and CO2 emissions (% of total fuel combustion) in Turkmenistan?
Your response must be concise. -40.87. In the year 1992, what is the difference between the CO2 emissions (% of total fuel combustion) of Australia and CO2 emissions (% of total fuel combustion) of Uzbekistan?
Your answer should be very brief. -47.64. In the year 1992, what is the difference between the CO2 emissions (% of total fuel combustion) in Nepal and CO2 emissions (% of total fuel combustion) in Turkmenistan?
Offer a very short reply. -31.48. In the year 1992, what is the difference between the CO2 emissions (% of total fuel combustion) in Nepal and CO2 emissions (% of total fuel combustion) in Uzbekistan?
Provide a succinct answer. -38.25. In the year 1992, what is the difference between the CO2 emissions (% of total fuel combustion) in Turkmenistan and CO2 emissions (% of total fuel combustion) in Uzbekistan?
Provide a succinct answer. -6.77. In the year 1993, what is the difference between the CO2 emissions (% of total fuel combustion) of Australia and CO2 emissions (% of total fuel combustion) of Nepal?
Provide a short and direct response. -9.61. In the year 1993, what is the difference between the CO2 emissions (% of total fuel combustion) of Australia and CO2 emissions (% of total fuel combustion) of Turkmenistan?
Offer a very short reply. -19.72. In the year 1993, what is the difference between the CO2 emissions (% of total fuel combustion) of Australia and CO2 emissions (% of total fuel combustion) of Uzbekistan?
Keep it short and to the point. -50.18. In the year 1993, what is the difference between the CO2 emissions (% of total fuel combustion) in Nepal and CO2 emissions (% of total fuel combustion) in Turkmenistan?
Provide a short and direct response. -10.1. In the year 1993, what is the difference between the CO2 emissions (% of total fuel combustion) of Nepal and CO2 emissions (% of total fuel combustion) of Uzbekistan?
Provide a short and direct response. -40.57. In the year 1993, what is the difference between the CO2 emissions (% of total fuel combustion) in Turkmenistan and CO2 emissions (% of total fuel combustion) in Uzbekistan?
Provide a short and direct response. -30.46. In the year 1994, what is the difference between the CO2 emissions (% of total fuel combustion) in Australia and CO2 emissions (% of total fuel combustion) in Nepal?
Your answer should be compact. -8.67. In the year 1994, what is the difference between the CO2 emissions (% of total fuel combustion) in Australia and CO2 emissions (% of total fuel combustion) in Turkmenistan?
Provide a succinct answer. -17. In the year 1994, what is the difference between the CO2 emissions (% of total fuel combustion) of Australia and CO2 emissions (% of total fuel combustion) of Uzbekistan?
Make the answer very short. -50.46. In the year 1994, what is the difference between the CO2 emissions (% of total fuel combustion) of Nepal and CO2 emissions (% of total fuel combustion) of Turkmenistan?
Provide a short and direct response. -8.33. In the year 1994, what is the difference between the CO2 emissions (% of total fuel combustion) of Nepal and CO2 emissions (% of total fuel combustion) of Uzbekistan?
Offer a very short reply. -41.79. In the year 1994, what is the difference between the CO2 emissions (% of total fuel combustion) of Turkmenistan and CO2 emissions (% of total fuel combustion) of Uzbekistan?
Your answer should be compact. -33.46. In the year 1995, what is the difference between the CO2 emissions (% of total fuel combustion) of Australia and CO2 emissions (% of total fuel combustion) of Nepal?
Keep it short and to the point. -9.02. In the year 1995, what is the difference between the CO2 emissions (% of total fuel combustion) in Australia and CO2 emissions (% of total fuel combustion) in Turkmenistan?
Provide a succinct answer. -15.38. In the year 1995, what is the difference between the CO2 emissions (% of total fuel combustion) in Australia and CO2 emissions (% of total fuel combustion) in Uzbekistan?
Keep it short and to the point. -7.49. In the year 1995, what is the difference between the CO2 emissions (% of total fuel combustion) in Nepal and CO2 emissions (% of total fuel combustion) in Turkmenistan?
Offer a very short reply. -6.36. In the year 1995, what is the difference between the CO2 emissions (% of total fuel combustion) in Nepal and CO2 emissions (% of total fuel combustion) in Uzbekistan?
Your response must be concise. 1.53. In the year 1995, what is the difference between the CO2 emissions (% of total fuel combustion) of Turkmenistan and CO2 emissions (% of total fuel combustion) of Uzbekistan?
Provide a short and direct response. 7.89. In the year 1996, what is the difference between the CO2 emissions (% of total fuel combustion) in Australia and CO2 emissions (% of total fuel combustion) in Nepal?
Keep it short and to the point. -9.22. In the year 1996, what is the difference between the CO2 emissions (% of total fuel combustion) of Australia and CO2 emissions (% of total fuel combustion) of Turkmenistan?
Keep it short and to the point. -19.88. In the year 1996, what is the difference between the CO2 emissions (% of total fuel combustion) in Australia and CO2 emissions (% of total fuel combustion) in Uzbekistan?
Ensure brevity in your answer.  -4.34. In the year 1996, what is the difference between the CO2 emissions (% of total fuel combustion) in Nepal and CO2 emissions (% of total fuel combustion) in Turkmenistan?
Make the answer very short. -10.66. In the year 1996, what is the difference between the CO2 emissions (% of total fuel combustion) of Nepal and CO2 emissions (% of total fuel combustion) of Uzbekistan?
Make the answer very short. 4.87. In the year 1996, what is the difference between the CO2 emissions (% of total fuel combustion) of Turkmenistan and CO2 emissions (% of total fuel combustion) of Uzbekistan?
Make the answer very short. 15.54. What is the ratio of the CO2 emissions (% of total fuel combustion) of Australia in 1990 to that in 1991?
Provide a succinct answer. 1. What is the ratio of the CO2 emissions (% of total fuel combustion) in Nepal in 1990 to that in 1991?
Provide a succinct answer. 1.15. What is the ratio of the CO2 emissions (% of total fuel combustion) in Turkmenistan in 1990 to that in 1991?
Provide a short and direct response. 1.12. What is the ratio of the CO2 emissions (% of total fuel combustion) in Uzbekistan in 1990 to that in 1991?
Your answer should be very brief. 1.01. What is the ratio of the CO2 emissions (% of total fuel combustion) in Australia in 1990 to that in 1992?
Your response must be concise. 0.98. What is the ratio of the CO2 emissions (% of total fuel combustion) in Nepal in 1990 to that in 1992?
Provide a short and direct response. 1.06. What is the ratio of the CO2 emissions (% of total fuel combustion) in Turkmenistan in 1990 to that in 1992?
Make the answer very short. 0.65. What is the ratio of the CO2 emissions (% of total fuel combustion) of Uzbekistan in 1990 to that in 1992?
Provide a short and direct response. 1.05. What is the ratio of the CO2 emissions (% of total fuel combustion) in Australia in 1990 to that in 1993?
Your answer should be compact. 0.98. What is the ratio of the CO2 emissions (% of total fuel combustion) in Nepal in 1990 to that in 1993?
Your answer should be very brief. 1.04. What is the ratio of the CO2 emissions (% of total fuel combustion) in Turkmenistan in 1990 to that in 1993?
Give a very brief answer. 1.31. What is the ratio of the CO2 emissions (% of total fuel combustion) in Australia in 1990 to that in 1994?
Provide a succinct answer. 0.98. What is the ratio of the CO2 emissions (% of total fuel combustion) of Nepal in 1990 to that in 1994?
Keep it short and to the point. 1.14. What is the ratio of the CO2 emissions (% of total fuel combustion) of Turkmenistan in 1990 to that in 1994?
Make the answer very short. 1.5. What is the ratio of the CO2 emissions (% of total fuel combustion) of Nepal in 1990 to that in 1995?
Ensure brevity in your answer.  1.1. What is the ratio of the CO2 emissions (% of total fuel combustion) in Turkmenistan in 1990 to that in 1995?
Your answer should be compact. 1.65. What is the ratio of the CO2 emissions (% of total fuel combustion) of Uzbekistan in 1990 to that in 1995?
Provide a short and direct response. 5.83. What is the ratio of the CO2 emissions (% of total fuel combustion) of Australia in 1990 to that in 1996?
Give a very brief answer. 1.02. What is the ratio of the CO2 emissions (% of total fuel combustion) in Nepal in 1990 to that in 1996?
Provide a short and direct response. 1.08. What is the ratio of the CO2 emissions (% of total fuel combustion) in Turkmenistan in 1990 to that in 1996?
Ensure brevity in your answer.  1.3. What is the ratio of the CO2 emissions (% of total fuel combustion) of Uzbekistan in 1990 to that in 1996?
Make the answer very short. 9.13. What is the ratio of the CO2 emissions (% of total fuel combustion) of Australia in 1991 to that in 1992?
Ensure brevity in your answer.  0.98. What is the ratio of the CO2 emissions (% of total fuel combustion) of Nepal in 1991 to that in 1992?
Give a very brief answer. 0.92. What is the ratio of the CO2 emissions (% of total fuel combustion) of Turkmenistan in 1991 to that in 1992?
Keep it short and to the point. 0.58. What is the ratio of the CO2 emissions (% of total fuel combustion) in Uzbekistan in 1991 to that in 1992?
Your response must be concise. 1.04. What is the ratio of the CO2 emissions (% of total fuel combustion) in Australia in 1991 to that in 1993?
Provide a short and direct response. 0.98. What is the ratio of the CO2 emissions (% of total fuel combustion) of Nepal in 1991 to that in 1993?
Offer a very short reply. 0.91. What is the ratio of the CO2 emissions (% of total fuel combustion) of Turkmenistan in 1991 to that in 1993?
Offer a terse response. 1.16. What is the ratio of the CO2 emissions (% of total fuel combustion) in Uzbekistan in 1991 to that in 1993?
Provide a short and direct response. 0.99. What is the ratio of the CO2 emissions (% of total fuel combustion) in Australia in 1991 to that in 1994?
Your response must be concise. 0.98. What is the ratio of the CO2 emissions (% of total fuel combustion) in Turkmenistan in 1991 to that in 1994?
Your answer should be very brief. 1.33. What is the ratio of the CO2 emissions (% of total fuel combustion) of Uzbekistan in 1991 to that in 1994?
Keep it short and to the point. 0.98. What is the ratio of the CO2 emissions (% of total fuel combustion) of Australia in 1991 to that in 1995?
Make the answer very short. 0.98. What is the ratio of the CO2 emissions (% of total fuel combustion) of Nepal in 1991 to that in 1995?
Offer a very short reply. 0.96. What is the ratio of the CO2 emissions (% of total fuel combustion) of Turkmenistan in 1991 to that in 1995?
Provide a short and direct response. 1.46. What is the ratio of the CO2 emissions (% of total fuel combustion) in Uzbekistan in 1991 to that in 1995?
Offer a terse response. 5.79. What is the ratio of the CO2 emissions (% of total fuel combustion) in Australia in 1991 to that in 1996?
Ensure brevity in your answer.  1.02. What is the ratio of the CO2 emissions (% of total fuel combustion) of Nepal in 1991 to that in 1996?
Make the answer very short. 0.94. What is the ratio of the CO2 emissions (% of total fuel combustion) of Turkmenistan in 1991 to that in 1996?
Ensure brevity in your answer.  1.16. What is the ratio of the CO2 emissions (% of total fuel combustion) of Uzbekistan in 1991 to that in 1996?
Offer a very short reply. 9.07. What is the ratio of the CO2 emissions (% of total fuel combustion) of Australia in 1992 to that in 1993?
Offer a terse response. 1. What is the ratio of the CO2 emissions (% of total fuel combustion) of Nepal in 1992 to that in 1993?
Keep it short and to the point. 0.98. What is the ratio of the CO2 emissions (% of total fuel combustion) in Turkmenistan in 1992 to that in 1993?
Make the answer very short. 2.01. What is the ratio of the CO2 emissions (% of total fuel combustion) in Uzbekistan in 1992 to that in 1993?
Offer a very short reply. 0.95. What is the ratio of the CO2 emissions (% of total fuel combustion) of Nepal in 1992 to that in 1994?
Keep it short and to the point. 1.07. What is the ratio of the CO2 emissions (% of total fuel combustion) of Turkmenistan in 1992 to that in 1994?
Provide a succinct answer. 2.3. What is the ratio of the CO2 emissions (% of total fuel combustion) in Uzbekistan in 1992 to that in 1994?
Ensure brevity in your answer.  0.95. What is the ratio of the CO2 emissions (% of total fuel combustion) in Nepal in 1992 to that in 1995?
Provide a succinct answer. 1.04. What is the ratio of the CO2 emissions (% of total fuel combustion) in Turkmenistan in 1992 to that in 1995?
Provide a succinct answer. 2.53. What is the ratio of the CO2 emissions (% of total fuel combustion) in Uzbekistan in 1992 to that in 1995?
Give a very brief answer. 5.56. What is the ratio of the CO2 emissions (% of total fuel combustion) of Australia in 1992 to that in 1996?
Ensure brevity in your answer.  1.04. What is the ratio of the CO2 emissions (% of total fuel combustion) in Nepal in 1992 to that in 1996?
Your answer should be compact. 1.02. What is the ratio of the CO2 emissions (% of total fuel combustion) of Turkmenistan in 1992 to that in 1996?
Your answer should be very brief. 1.99. What is the ratio of the CO2 emissions (% of total fuel combustion) in Uzbekistan in 1992 to that in 1996?
Offer a terse response. 8.71. What is the ratio of the CO2 emissions (% of total fuel combustion) in Australia in 1993 to that in 1994?
Give a very brief answer. 1. What is the ratio of the CO2 emissions (% of total fuel combustion) in Nepal in 1993 to that in 1994?
Keep it short and to the point. 1.09. What is the ratio of the CO2 emissions (% of total fuel combustion) of Turkmenistan in 1993 to that in 1994?
Your answer should be very brief. 1.15. What is the ratio of the CO2 emissions (% of total fuel combustion) of Nepal in 1993 to that in 1995?
Give a very brief answer. 1.06. What is the ratio of the CO2 emissions (% of total fuel combustion) of Turkmenistan in 1993 to that in 1995?
Keep it short and to the point. 1.26. What is the ratio of the CO2 emissions (% of total fuel combustion) of Uzbekistan in 1993 to that in 1995?
Keep it short and to the point. 5.85. What is the ratio of the CO2 emissions (% of total fuel combustion) in Australia in 1993 to that in 1996?
Offer a very short reply. 1.03. What is the ratio of the CO2 emissions (% of total fuel combustion) in Nepal in 1993 to that in 1996?
Give a very brief answer. 1.04. What is the ratio of the CO2 emissions (% of total fuel combustion) in Turkmenistan in 1993 to that in 1996?
Offer a very short reply. 0.99. What is the ratio of the CO2 emissions (% of total fuel combustion) in Uzbekistan in 1993 to that in 1996?
Offer a very short reply. 9.16. What is the ratio of the CO2 emissions (% of total fuel combustion) of Australia in 1994 to that in 1995?
Your response must be concise. 1. What is the ratio of the CO2 emissions (% of total fuel combustion) in Nepal in 1994 to that in 1995?
Your response must be concise. 0.97. What is the ratio of the CO2 emissions (% of total fuel combustion) in Turkmenistan in 1994 to that in 1995?
Ensure brevity in your answer.  1.1. What is the ratio of the CO2 emissions (% of total fuel combustion) in Uzbekistan in 1994 to that in 1995?
Keep it short and to the point. 5.88. What is the ratio of the CO2 emissions (% of total fuel combustion) of Australia in 1994 to that in 1996?
Your response must be concise. 1.04. What is the ratio of the CO2 emissions (% of total fuel combustion) of Nepal in 1994 to that in 1996?
Your answer should be compact. 0.95. What is the ratio of the CO2 emissions (% of total fuel combustion) of Turkmenistan in 1994 to that in 1996?
Keep it short and to the point. 0.87. What is the ratio of the CO2 emissions (% of total fuel combustion) of Uzbekistan in 1994 to that in 1996?
Your response must be concise. 9.21. What is the ratio of the CO2 emissions (% of total fuel combustion) of Australia in 1995 to that in 1996?
Provide a succinct answer. 1.04. What is the ratio of the CO2 emissions (% of total fuel combustion) of Nepal in 1995 to that in 1996?
Your answer should be very brief. 0.99. What is the ratio of the CO2 emissions (% of total fuel combustion) in Turkmenistan in 1995 to that in 1996?
Offer a terse response. 0.79. What is the ratio of the CO2 emissions (% of total fuel combustion) of Uzbekistan in 1995 to that in 1996?
Your response must be concise. 1.57. What is the difference between the highest and the second highest CO2 emissions (% of total fuel combustion) of Australia?
Make the answer very short. 0. What is the difference between the highest and the second highest CO2 emissions (% of total fuel combustion) in Nepal?
Offer a terse response. 0.43. What is the difference between the highest and the second highest CO2 emissions (% of total fuel combustion) of Turkmenistan?
Provide a short and direct response. 14.72. What is the difference between the highest and the second highest CO2 emissions (% of total fuel combustion) in Uzbekistan?
Offer a terse response. 0.28. What is the difference between the highest and the lowest CO2 emissions (% of total fuel combustion) in Australia?
Your response must be concise. 0.05. What is the difference between the highest and the lowest CO2 emissions (% of total fuel combustion) of Nepal?
Offer a terse response. 1.45. What is the difference between the highest and the lowest CO2 emissions (% of total fuel combustion) of Turkmenistan?
Your answer should be very brief. 25.49. What is the difference between the highest and the lowest CO2 emissions (% of total fuel combustion) of Uzbekistan?
Provide a succinct answer. 46.16. 